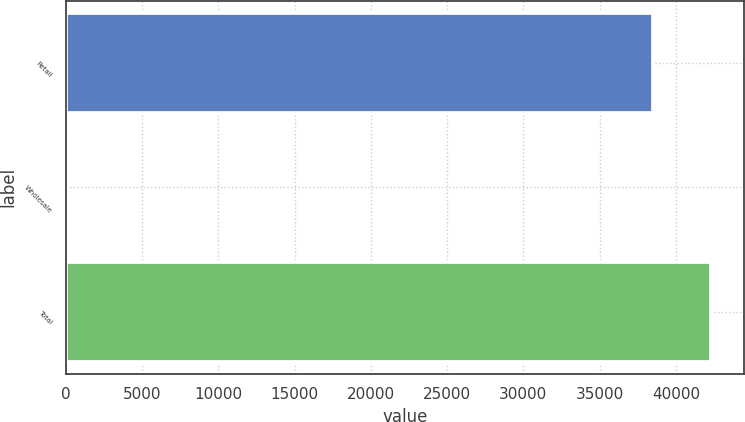<chart> <loc_0><loc_0><loc_500><loc_500><bar_chart><fcel>Retail<fcel>Wholesale<fcel>Total<nl><fcel>38486<fcel>72<fcel>42334.6<nl></chart> 